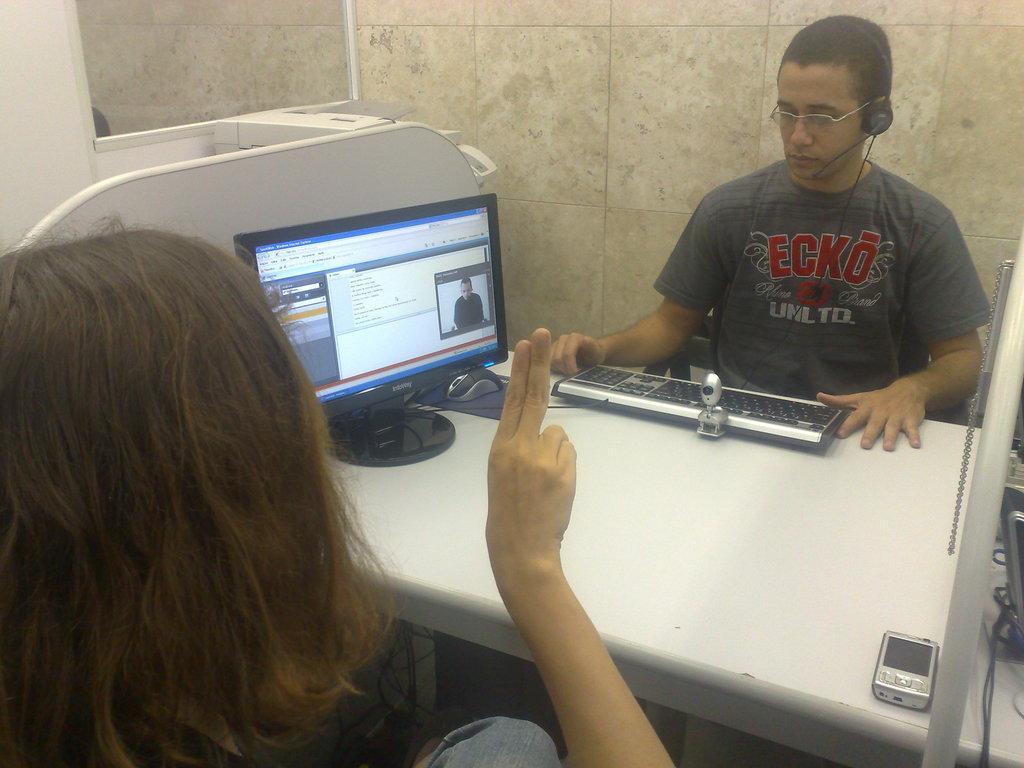How would you summarize this image in a sentence or two? In this image we can see a man and the man is wearing headphones. In front of the man we can see a monitor, keyboard, mouse and a mobile. To the keyboard a camera is attached and on the monitor we can see a tab and an image of a person. At the bottom we can see another person. In the background, we can see a wall. In the top left, we can see a mirror. 